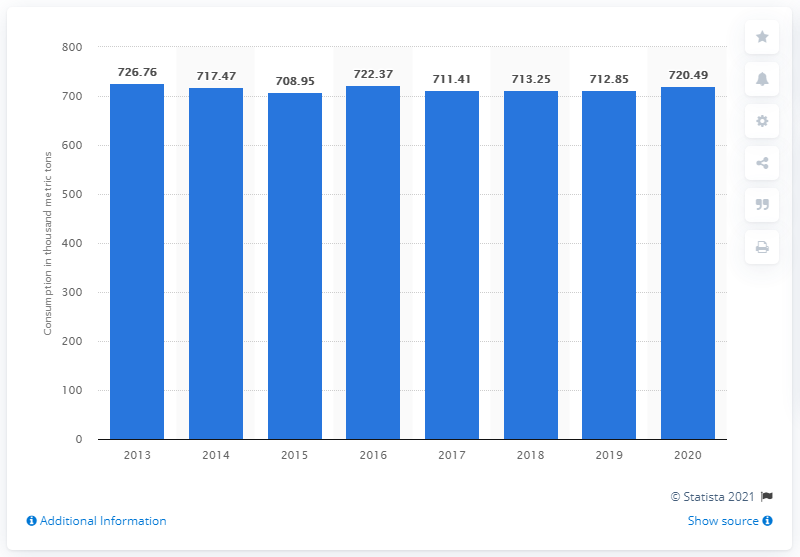Mention a couple of crucial points in this snapshot. In 2013, India began to consume more sheep meat. 